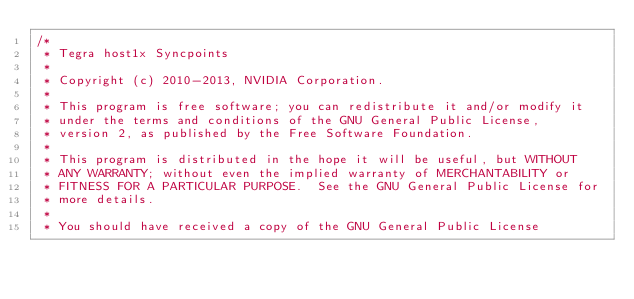<code> <loc_0><loc_0><loc_500><loc_500><_C_>/*
 * Tegra host1x Syncpoints
 *
 * Copyright (c) 2010-2013, NVIDIA Corporation.
 *
 * This program is free software; you can redistribute it and/or modify it
 * under the terms and conditions of the GNU General Public License,
 * version 2, as published by the Free Software Foundation.
 *
 * This program is distributed in the hope it will be useful, but WITHOUT
 * ANY WARRANTY; without even the implied warranty of MERCHANTABILITY or
 * FITNESS FOR A PARTICULAR PURPOSE.  See the GNU General Public License for
 * more details.
 *
 * You should have received a copy of the GNU General Public License</code> 